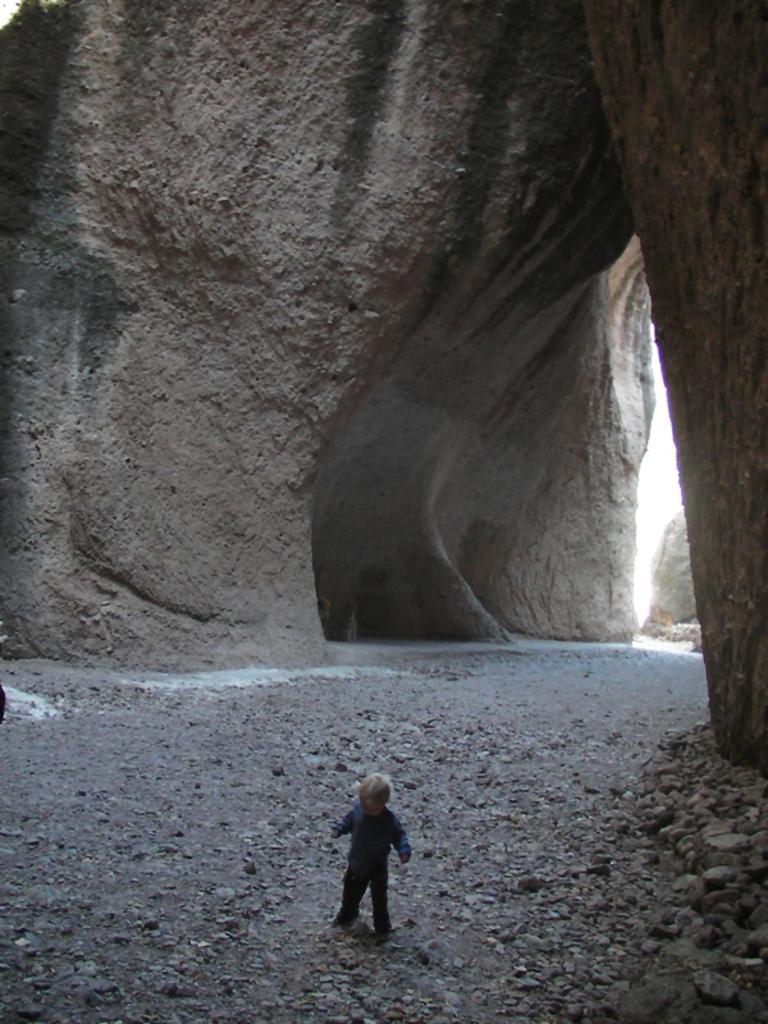Could you give a brief overview of what you see in this image? In this image we can see a kid. We can also see the rock hill, stones and also the sky. 